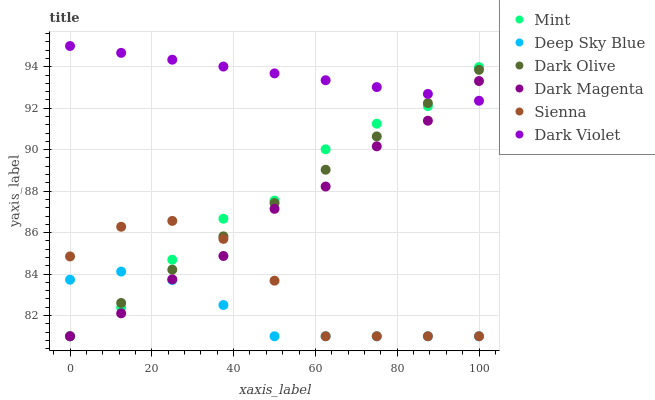Does Deep Sky Blue have the minimum area under the curve?
Answer yes or no. Yes. Does Dark Violet have the maximum area under the curve?
Answer yes or no. Yes. Does Dark Olive have the minimum area under the curve?
Answer yes or no. No. Does Dark Olive have the maximum area under the curve?
Answer yes or no. No. Is Dark Violet the smoothest?
Answer yes or no. Yes. Is Sienna the roughest?
Answer yes or no. Yes. Is Dark Olive the smoothest?
Answer yes or no. No. Is Dark Olive the roughest?
Answer yes or no. No. Does Dark Magenta have the lowest value?
Answer yes or no. Yes. Does Dark Violet have the lowest value?
Answer yes or no. No. Does Dark Violet have the highest value?
Answer yes or no. Yes. Does Dark Olive have the highest value?
Answer yes or no. No. Is Sienna less than Dark Violet?
Answer yes or no. Yes. Is Dark Violet greater than Sienna?
Answer yes or no. Yes. Does Dark Violet intersect Dark Olive?
Answer yes or no. Yes. Is Dark Violet less than Dark Olive?
Answer yes or no. No. Is Dark Violet greater than Dark Olive?
Answer yes or no. No. Does Sienna intersect Dark Violet?
Answer yes or no. No. 